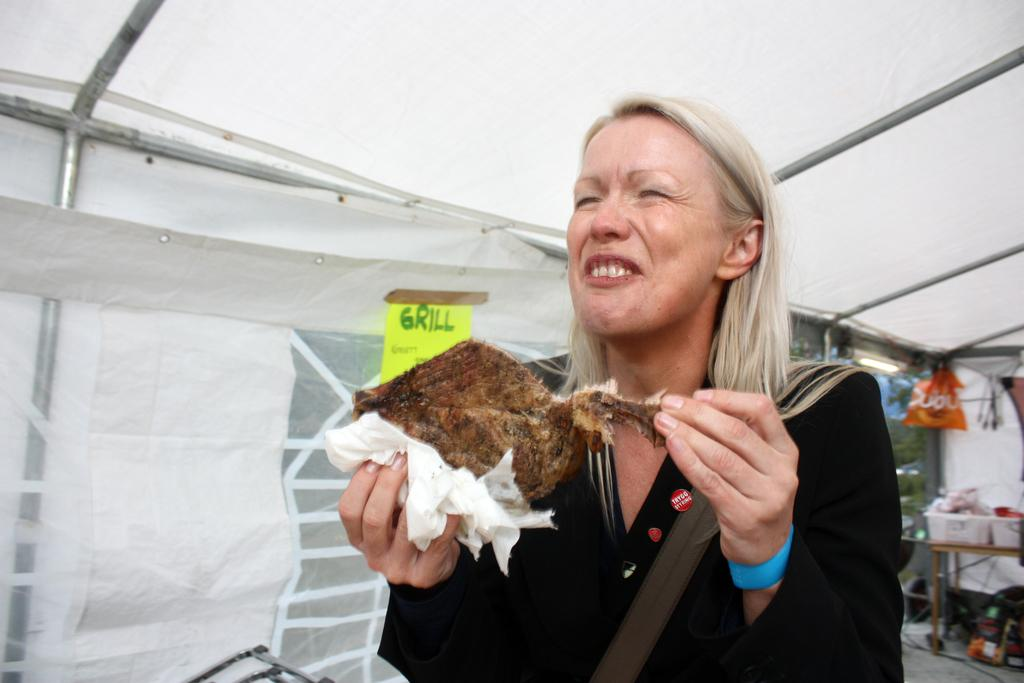Who is present in the image? There is a woman in the image. What is the woman holding in the image? The woman is holding a grilled food item. What objects can be seen in the image that are used for cooking or grilling? There are rods visible in the image, which might be used for grilling. What type of container is present in the image? There is a bag in the image. How many tubs with items are visible in the image? There are two tubs with items in the image. What type of furniture is present in the image? There is a table in the image. What type of balloon is being used in the grilling process in the image? There is no balloon present in the image, and no balloons are used in the grilling process. 